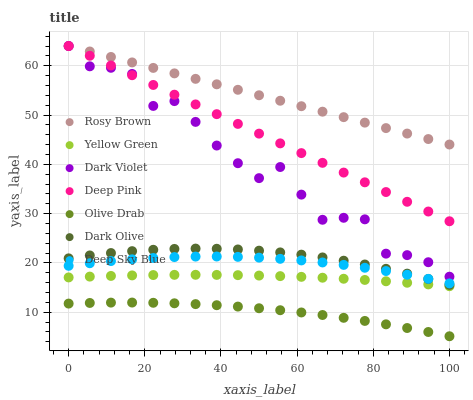Does Olive Drab have the minimum area under the curve?
Answer yes or no. Yes. Does Rosy Brown have the maximum area under the curve?
Answer yes or no. Yes. Does Yellow Green have the minimum area under the curve?
Answer yes or no. No. Does Yellow Green have the maximum area under the curve?
Answer yes or no. No. Is Rosy Brown the smoothest?
Answer yes or no. Yes. Is Dark Violet the roughest?
Answer yes or no. Yes. Is Yellow Green the smoothest?
Answer yes or no. No. Is Yellow Green the roughest?
Answer yes or no. No. Does Olive Drab have the lowest value?
Answer yes or no. Yes. Does Yellow Green have the lowest value?
Answer yes or no. No. Does Deep Pink have the highest value?
Answer yes or no. Yes. Does Yellow Green have the highest value?
Answer yes or no. No. Is Olive Drab less than Dark Violet?
Answer yes or no. Yes. Is Dark Violet greater than Dark Olive?
Answer yes or no. Yes. Does Dark Violet intersect Rosy Brown?
Answer yes or no. Yes. Is Dark Violet less than Rosy Brown?
Answer yes or no. No. Is Dark Violet greater than Rosy Brown?
Answer yes or no. No. Does Olive Drab intersect Dark Violet?
Answer yes or no. No. 